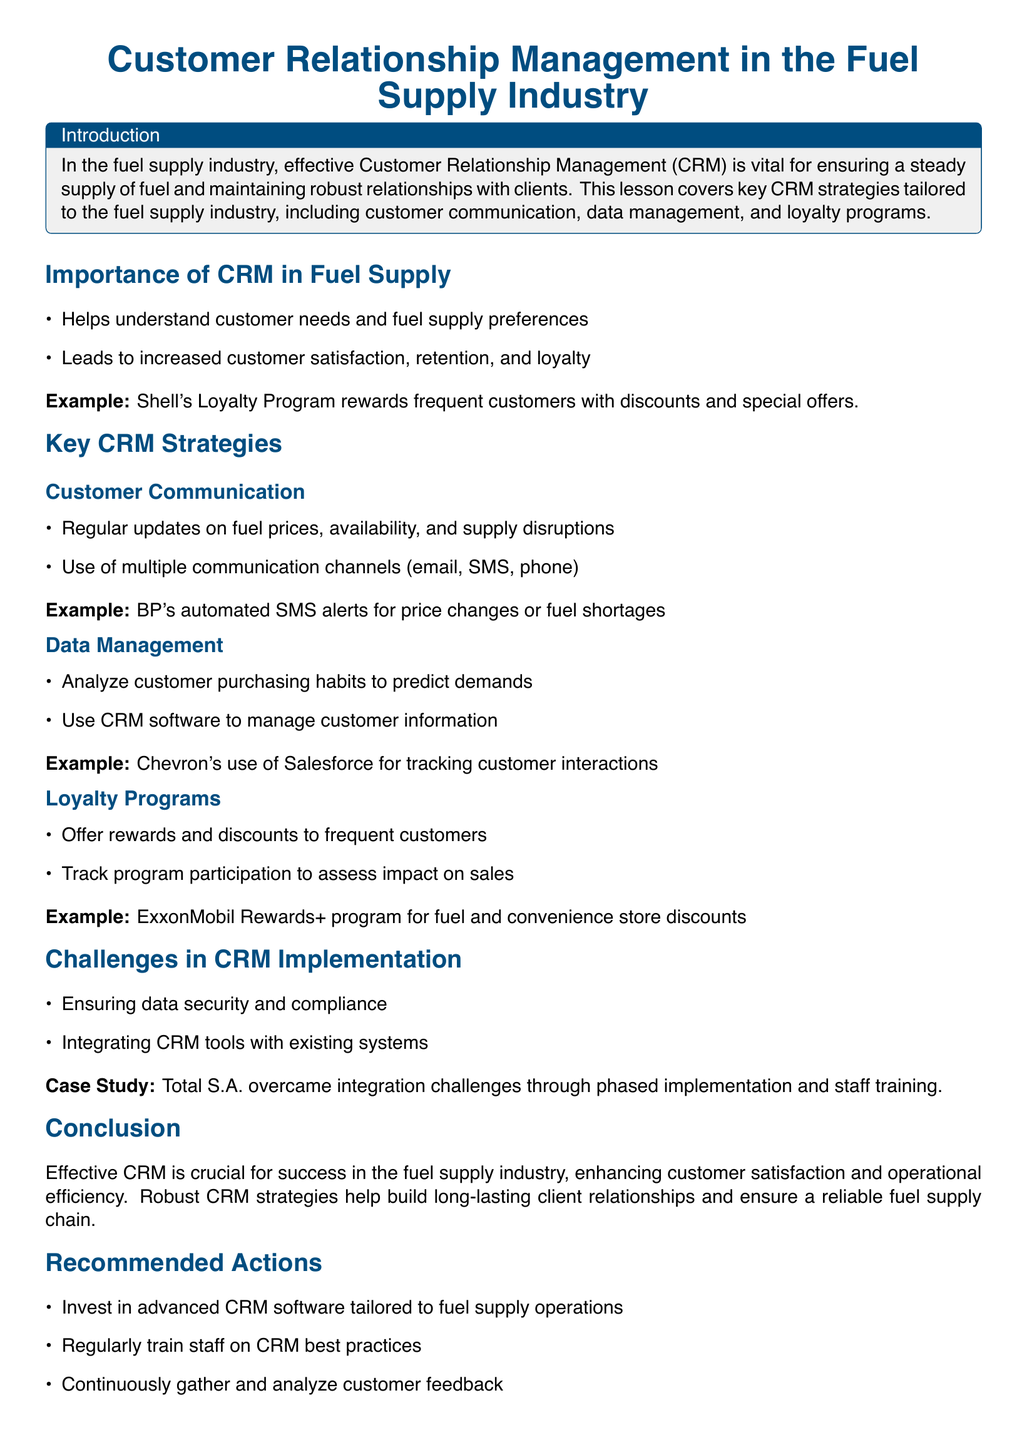What is the title of the lesson plan? The title is the main heading of the document, which is centered and prominently displayed.
Answer: Customer Relationship Management in the Fuel Supply Industry What color is used for the main title? The color is specified for the title text to distinguish it visually.
Answer: Oil blue Which company’s loyalty program is mentioned as an example? It provides specific examples of CRM strategies used by leading companies in the fuel supply industry.
Answer: Shell What is one of the key CRM strategies outlined in the lesson plan? The document lists several strategies under clearly defined sections.
Answer: Customer Communication What software does Chevron use for tracking customer interactions? The document mentions specific software utilized by companies in the industry for CRM purposes.
Answer: Salesforce What is a challenge in CRM implementation according to the document? The lesson plan identifies specific challenges faced by companies in integrating CRM systems.
Answer: Data security Which CRM strategy involves tracking program participation? It provides insights into different aspects of CRM and their functions, including rewards systems.
Answer: Loyalty Programs How many recommended actions are listed in the conclusion? The document enumerates specific actions for effective CRM implementation in the fuel supply industry.
Answer: Three 